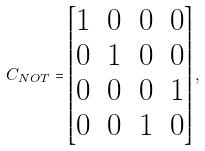<formula> <loc_0><loc_0><loc_500><loc_500>C _ { N O T } = \left [ \begin{matrix} 1 & 0 & 0 & 0 \\ 0 & 1 & 0 & 0 \\ 0 & 0 & 0 & 1 \\ 0 & 0 & 1 & 0 \end{matrix} \right ] ,</formula> 